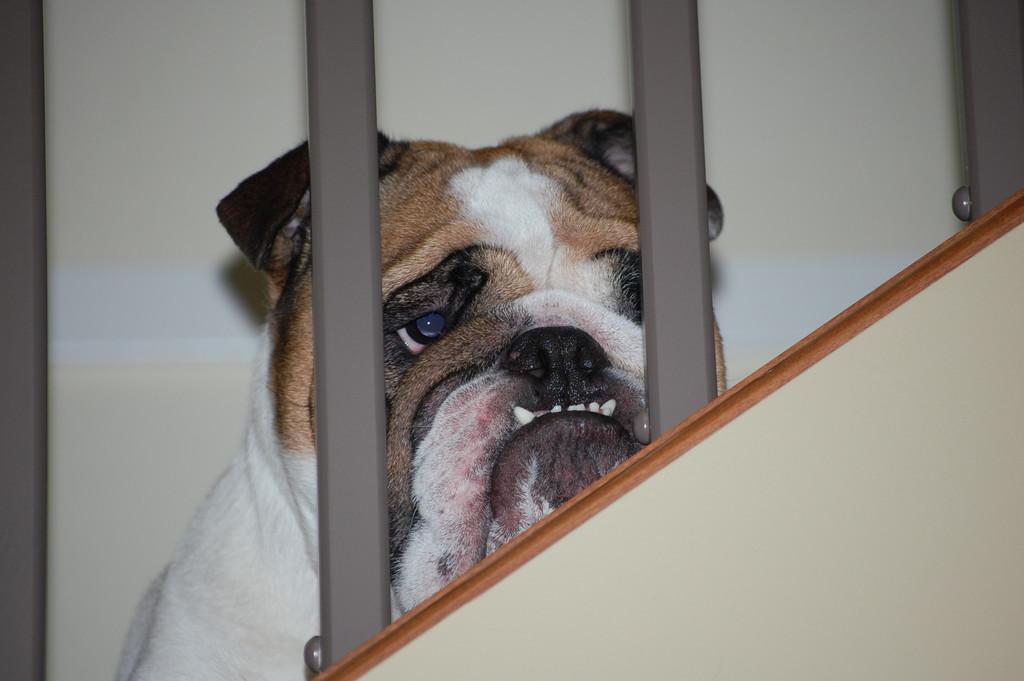Describe this image in one or two sentences. This image consists of a dog in white and brown color. In the front, we can see the metal rods. It looks like the dog is sitting on the stairs. In the background, there is a wall. 